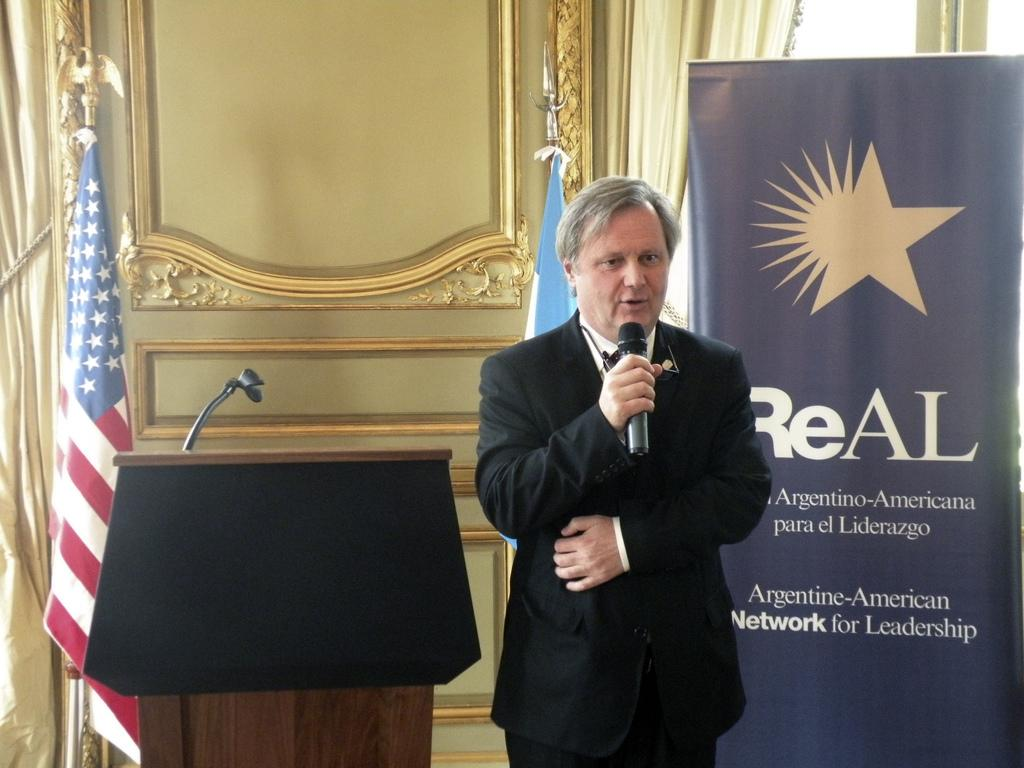What is the man in the image doing? The man is standing in the image and holding a microphone. What else can be seen in the image besides the man? There is a banner, a stand above a podium, flags, and curtains visible in the image. What might the man be using the microphone for? The man might be using the microphone for speaking or presenting at an event. What is the purpose of the stand above the podium? The stand above the podium might be used for holding a presentation or displaying information. What type of beast can be seen hiding behind the curtains in the image? There is no beast present in the image; only the man, microphone, banner, stand, podium, flags, and curtains are visible. 